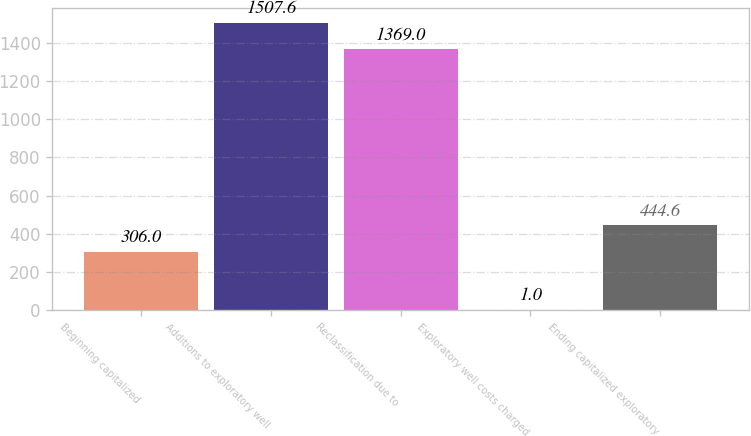Convert chart. <chart><loc_0><loc_0><loc_500><loc_500><bar_chart><fcel>Beginning capitalized<fcel>Additions to exploratory well<fcel>Reclassification due to<fcel>Exploratory well costs charged<fcel>Ending capitalized exploratory<nl><fcel>306<fcel>1507.6<fcel>1369<fcel>1<fcel>444.6<nl></chart> 